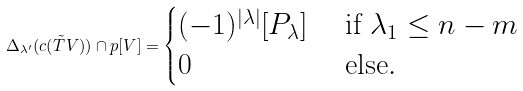Convert formula to latex. <formula><loc_0><loc_0><loc_500><loc_500>\Delta _ { \lambda ^ { \prime } } ( c ( \tilde { T } V ) ) \cap p [ V ] = \begin{cases} ( - 1 ) ^ { | \lambda | } [ P _ { \lambda } ] & \text { if } \lambda _ { 1 } \leq n - m \\ 0 & \text { else} . \end{cases}</formula> 